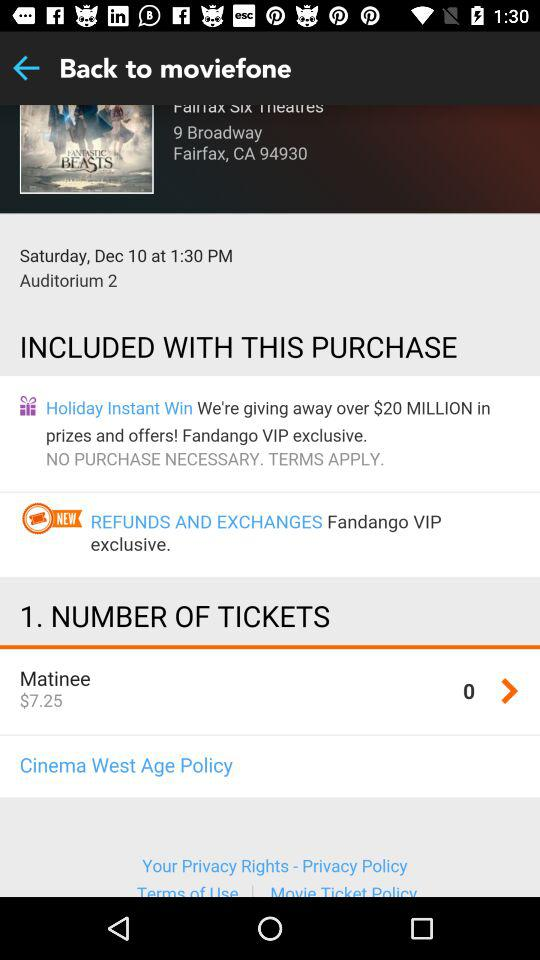How many tickets are being purchased?
Answer the question using a single word or phrase. 1 